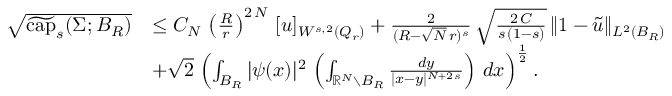<formula> <loc_0><loc_0><loc_500><loc_500>\begin{array} { r l } { \sqrt { \widetilde { c a p } _ { s } ( \Sigma ; B _ { R } ) } } & { \leq C _ { N } \, \left ( \frac { R } { r } \right ) ^ { 2 \, N } \, [ u ] _ { W ^ { s , 2 } ( Q _ { r } ) } + \frac { 2 } { ( R - \sqrt { N } \, r ) ^ { s } } \, \sqrt { \frac { 2 \, C } { s \, ( 1 - s ) } } \, \| 1 - \widetilde { u } \| _ { L ^ { 2 } ( B _ { R } ) } } \\ & { + \sqrt { 2 } \, \left ( \int _ { B _ { R } } | \psi ( x ) | ^ { 2 } \, \left ( \int _ { \mathbb { R } ^ { N } \ B _ { R } } \frac { d y } { | x - y | ^ { N + 2 \, s } } \right ) \, d x \right ) ^ { \frac { 1 } { 2 } } . } \end{array}</formula> 